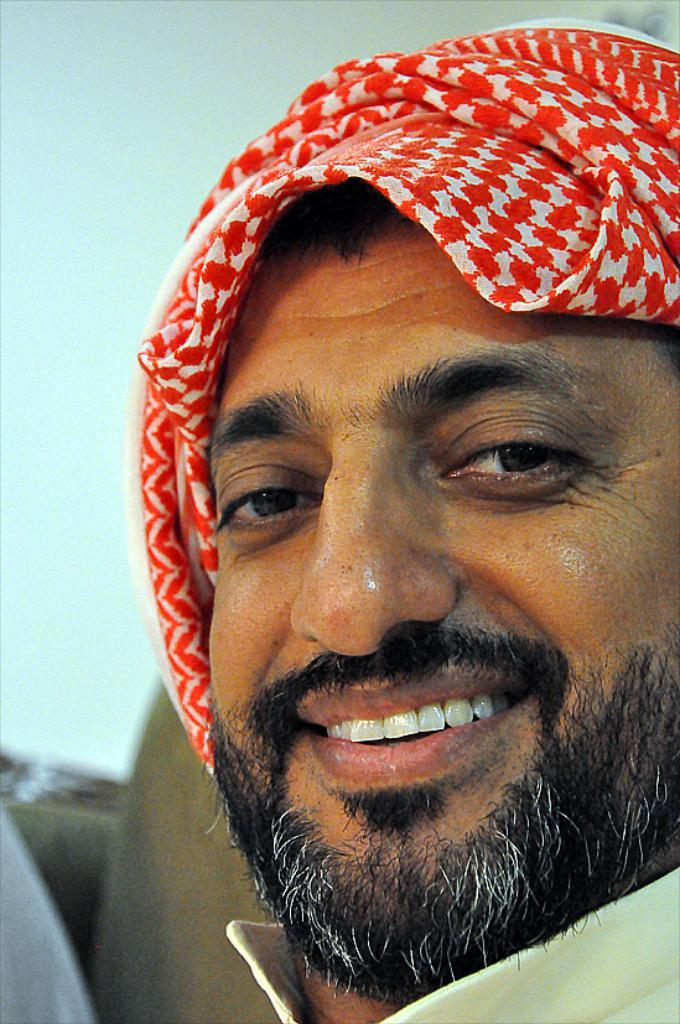Who is present in the image? There is a man in the image. What is the man wearing on his head? The man is wearing a red color head scarf. What is the man's facial expression? The man is smiling. What is the man looking at? The man is looking at a picture. What can be seen in the background of the image? There is a wall in the background of the image. What type of pencil can be seen in the man's hand in the image? There is no pencil visible in the man's hand in the image. What material is the card that the man is holding in the image made of? There is no card visible in the man's hand in the image. 